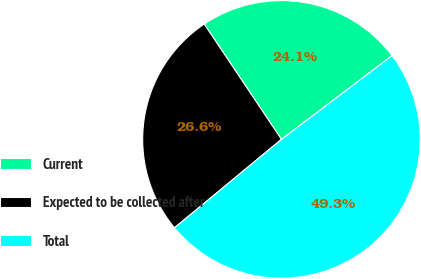Convert chart to OTSL. <chart><loc_0><loc_0><loc_500><loc_500><pie_chart><fcel>Current<fcel>Expected to be collected after<fcel>Total<nl><fcel>24.08%<fcel>26.6%<fcel>49.32%<nl></chart> 